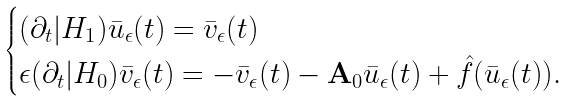<formula> <loc_0><loc_0><loc_500><loc_500>\begin{cases} ( \partial _ { t } | H _ { 1 } ) \bar { u } _ { \epsilon } ( t ) = \bar { v } _ { \epsilon } ( t ) \\ \epsilon ( \partial _ { t } | H _ { 0 } ) \bar { v } _ { \epsilon } ( t ) = - \bar { v } _ { \epsilon } ( t ) - \mathbf A _ { 0 } \bar { u } _ { \epsilon } ( t ) + \hat { f } ( \bar { u } _ { \epsilon } ( t ) ) . \end{cases}</formula> 